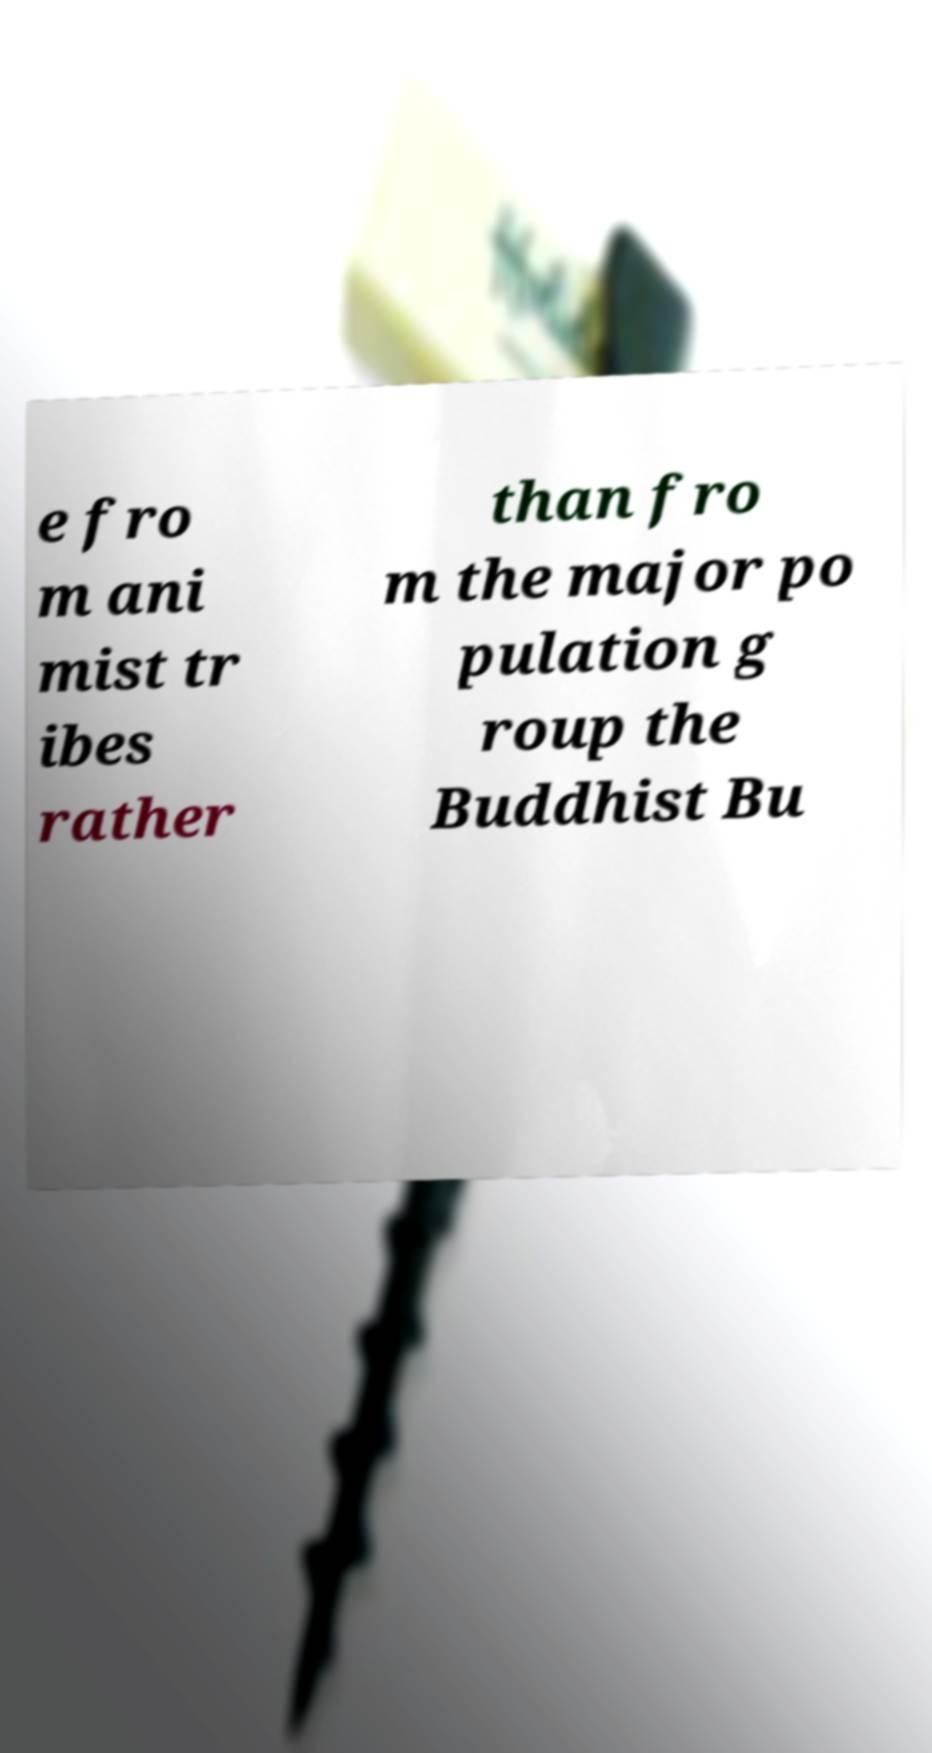Can you read and provide the text displayed in the image?This photo seems to have some interesting text. Can you extract and type it out for me? e fro m ani mist tr ibes rather than fro m the major po pulation g roup the Buddhist Bu 